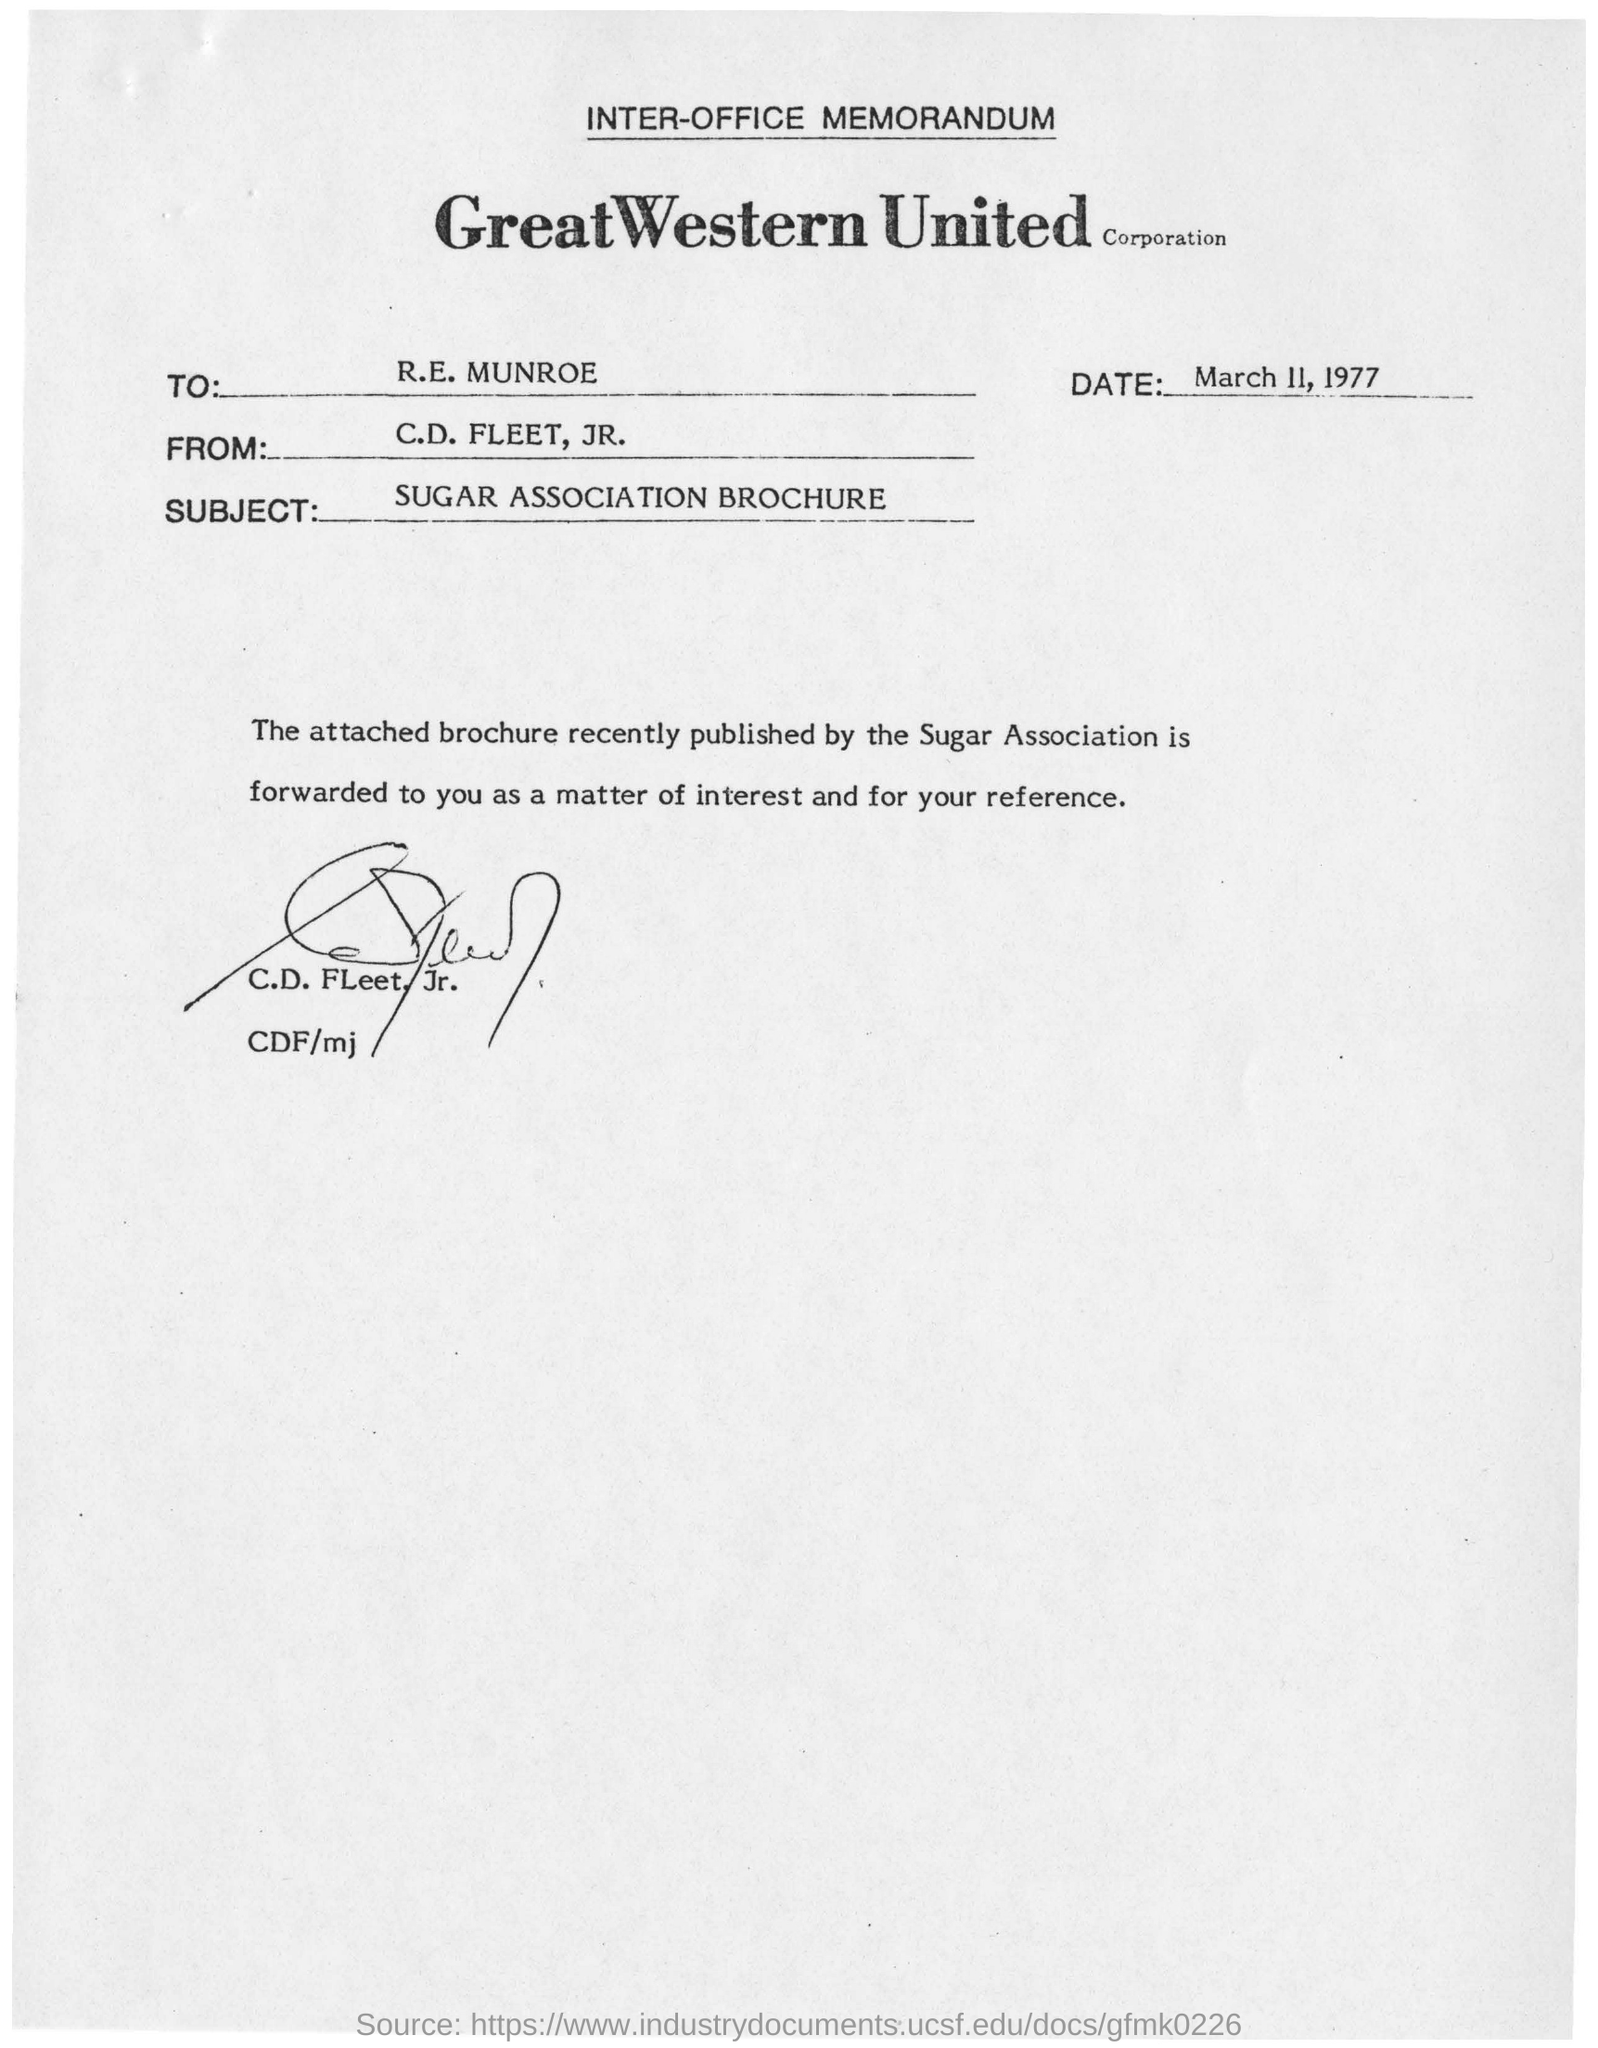To whom the memorandum is addressed to?
Keep it short and to the point. R.E. MUNROE. Subject of the letter
Your response must be concise. Sugar association brochure. Who published a brochure recently?
Your response must be concise. Sugar association. Who has signed this memorandum?
Give a very brief answer. C.D. Fleet, Jr. 